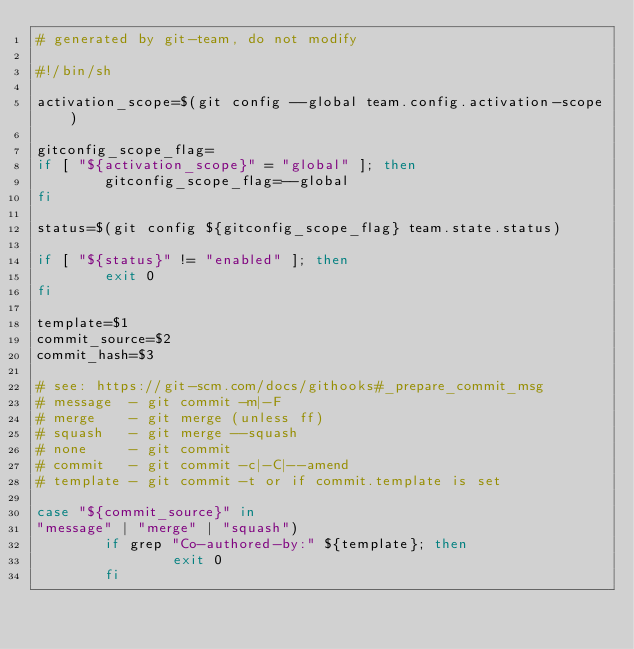Convert code to text. <code><loc_0><loc_0><loc_500><loc_500><_Bash_># generated by git-team, do not modify

#!/bin/sh

activation_scope=$(git config --global team.config.activation-scope)

gitconfig_scope_flag=
if [ "${activation_scope}" = "global" ]; then
        gitconfig_scope_flag=--global
fi

status=$(git config ${gitconfig_scope_flag} team.state.status)

if [ "${status}" != "enabled" ]; then
        exit 0
fi

template=$1
commit_source=$2
commit_hash=$3

# see: https://git-scm.com/docs/githooks#_prepare_commit_msg
# message  - git commit -m|-F
# merge    - git merge (unless ff)
# squash   - git merge --squash
# none     - git commit
# commit   - git commit -c|-C|--amend
# template - git commit -t or if commit.template is set

case "${commit_source}" in
"message" | "merge" | "squash")
        if grep "Co-authored-by:" ${template}; then
                exit 0
        fi
</code> 